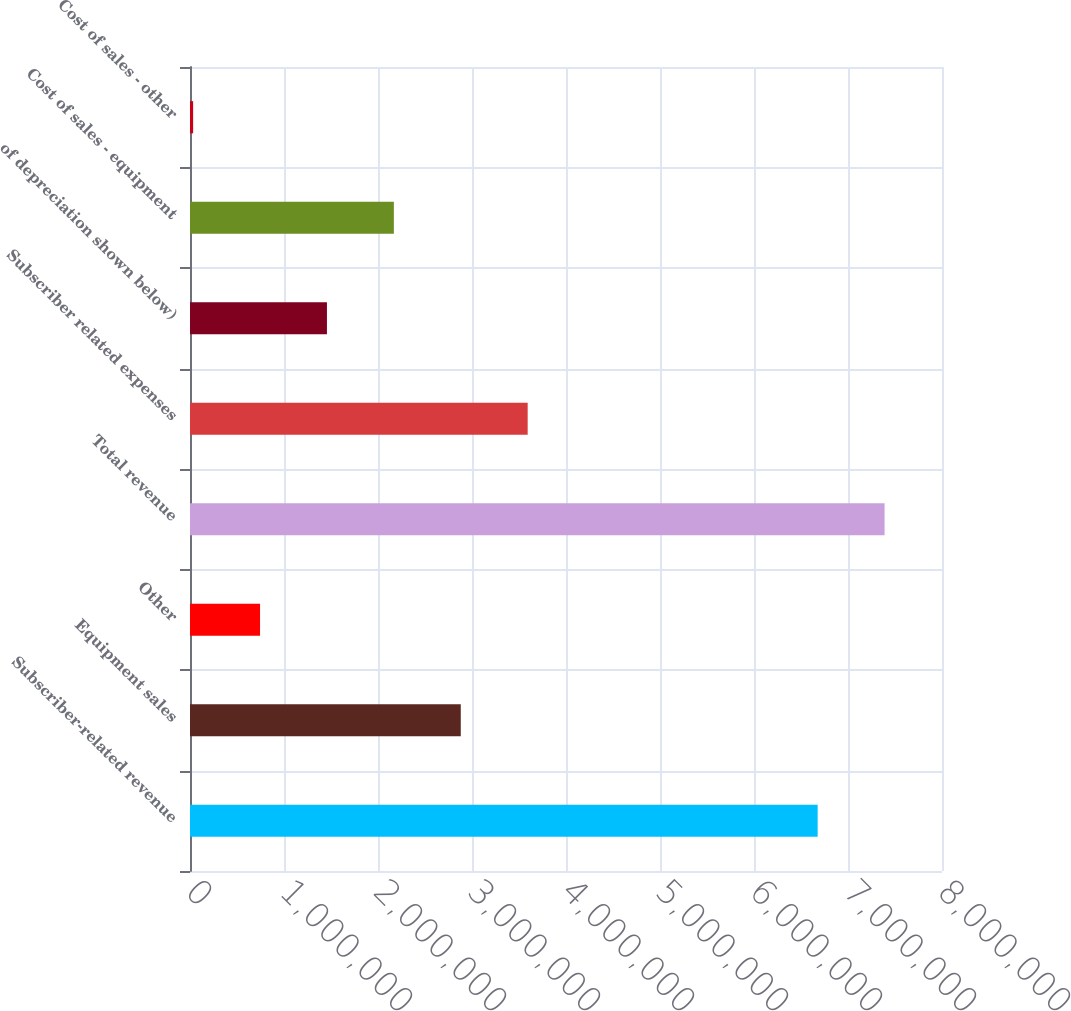Convert chart. <chart><loc_0><loc_0><loc_500><loc_500><bar_chart><fcel>Subscriber-related revenue<fcel>Equipment sales<fcel>Other<fcel>Total revenue<fcel>Subscriber related expenses<fcel>of depreciation shown below)<fcel>Cost of sales - equipment<fcel>Cost of sales - other<nl><fcel>6.67737e+06<fcel>2.88045e+06<fcel>745060<fcel>7.38917e+06<fcel>3.59224e+06<fcel>1.45686e+06<fcel>2.16865e+06<fcel>33265<nl></chart> 